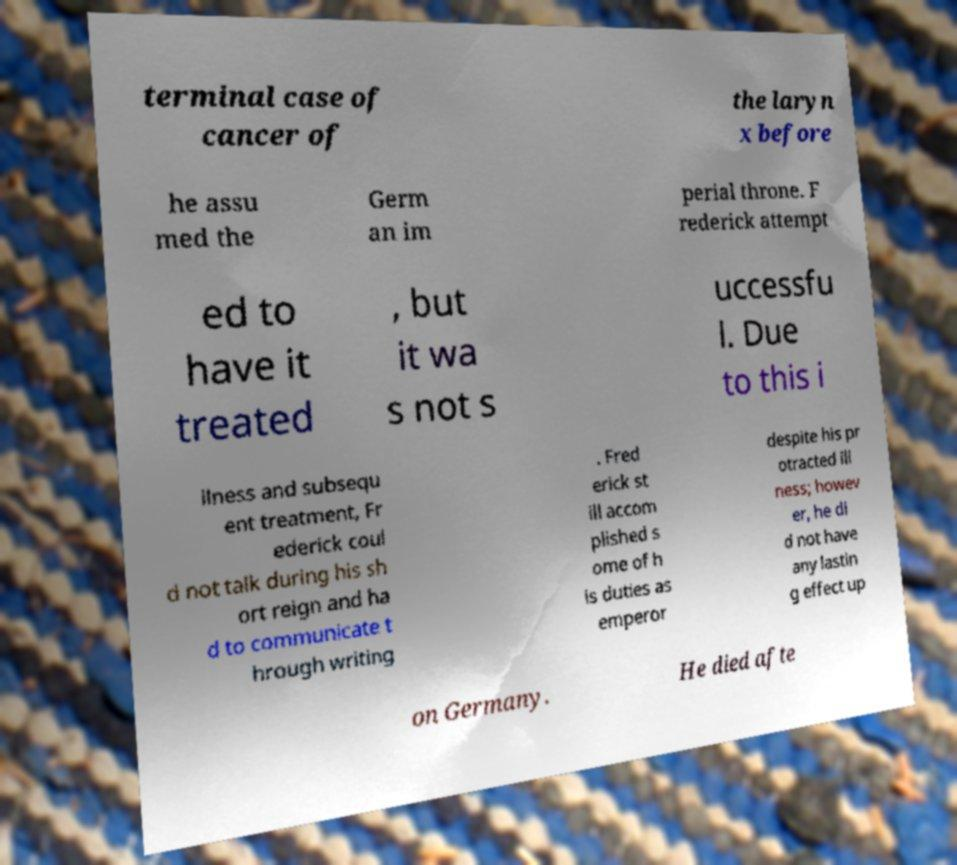What messages or text are displayed in this image? I need them in a readable, typed format. terminal case of cancer of the laryn x before he assu med the Germ an im perial throne. F rederick attempt ed to have it treated , but it wa s not s uccessfu l. Due to this i llness and subsequ ent treatment, Fr ederick coul d not talk during his sh ort reign and ha d to communicate t hrough writing . Fred erick st ill accom plished s ome of h is duties as emperor despite his pr otracted ill ness; howev er, he di d not have any lastin g effect up on Germany. He died afte 